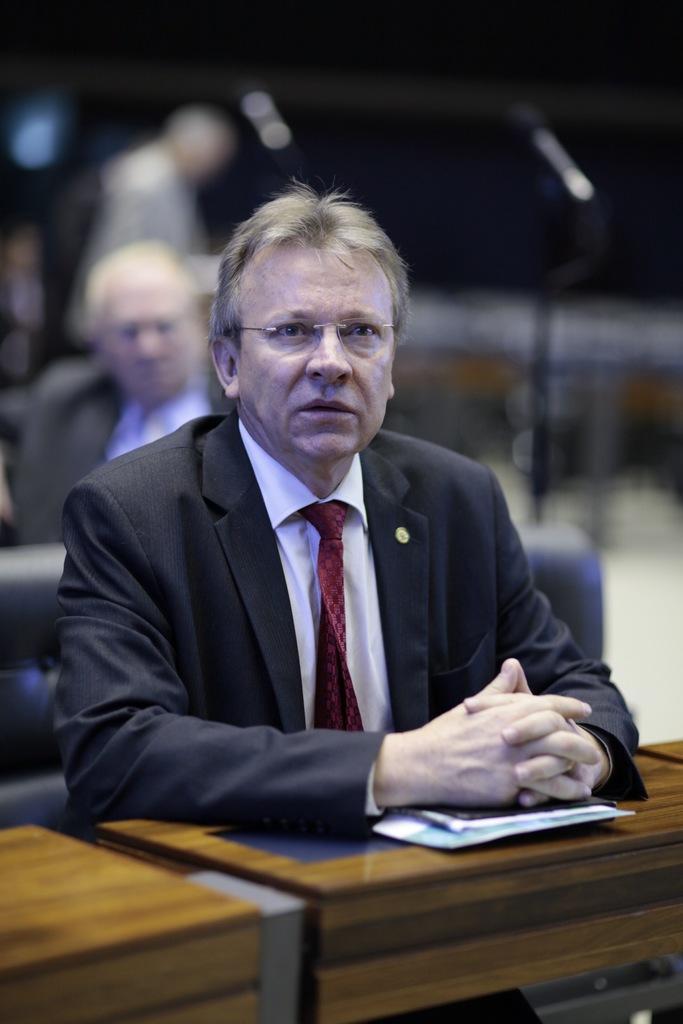In one or two sentences, can you explain what this image depicts? In this picture I can see a man who is sitting and I see that he is wearing formal dress and I see a table in front of him. In the background I see few people and I see that it is blurred and I can also see another table on the left bottom corner of this image. 